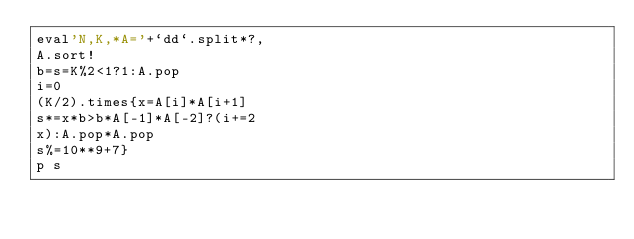Convert code to text. <code><loc_0><loc_0><loc_500><loc_500><_Ruby_>eval'N,K,*A='+`dd`.split*?,
A.sort!
b=s=K%2<1?1:A.pop
i=0
(K/2).times{x=A[i]*A[i+1]
s*=x*b>b*A[-1]*A[-2]?(i+=2
x):A.pop*A.pop
s%=10**9+7}
p s</code> 